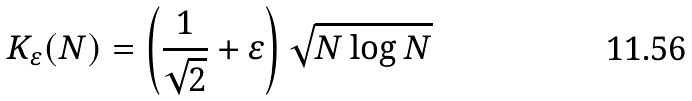Convert formula to latex. <formula><loc_0><loc_0><loc_500><loc_500>K _ { \varepsilon } ( N ) = \left ( \frac { 1 } { \sqrt { 2 } } + \varepsilon \right ) \sqrt { N \log N }</formula> 